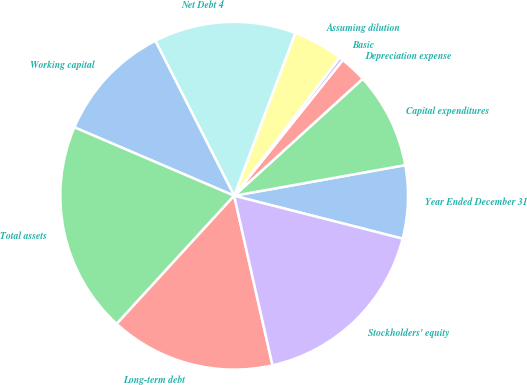Convert chart. <chart><loc_0><loc_0><loc_500><loc_500><pie_chart><fcel>Year Ended December 31<fcel>Capital expenditures<fcel>Depreciation expense<fcel>Basic<fcel>Assuming dilution<fcel>Net Debt 4<fcel>Working capital<fcel>Total assets<fcel>Long-term debt<fcel>Stockholders' equity<nl><fcel>6.79%<fcel>8.93%<fcel>2.51%<fcel>0.37%<fcel>4.65%<fcel>13.21%<fcel>11.07%<fcel>19.63%<fcel>15.35%<fcel>17.49%<nl></chart> 